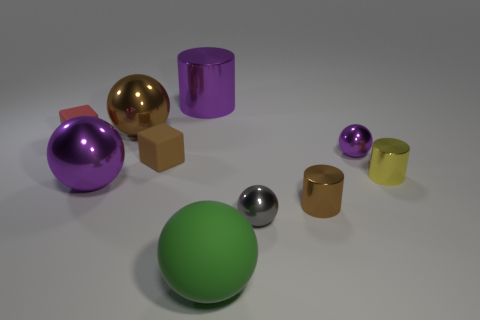Subtract all large purple shiny balls. How many balls are left? 4 Subtract all cyan balls. Subtract all brown cylinders. How many balls are left? 5 Subtract all cubes. How many objects are left? 8 Subtract all big gray cylinders. Subtract all green rubber objects. How many objects are left? 9 Add 1 brown matte things. How many brown matte things are left? 2 Add 3 large brown objects. How many large brown objects exist? 4 Subtract 0 yellow blocks. How many objects are left? 10 